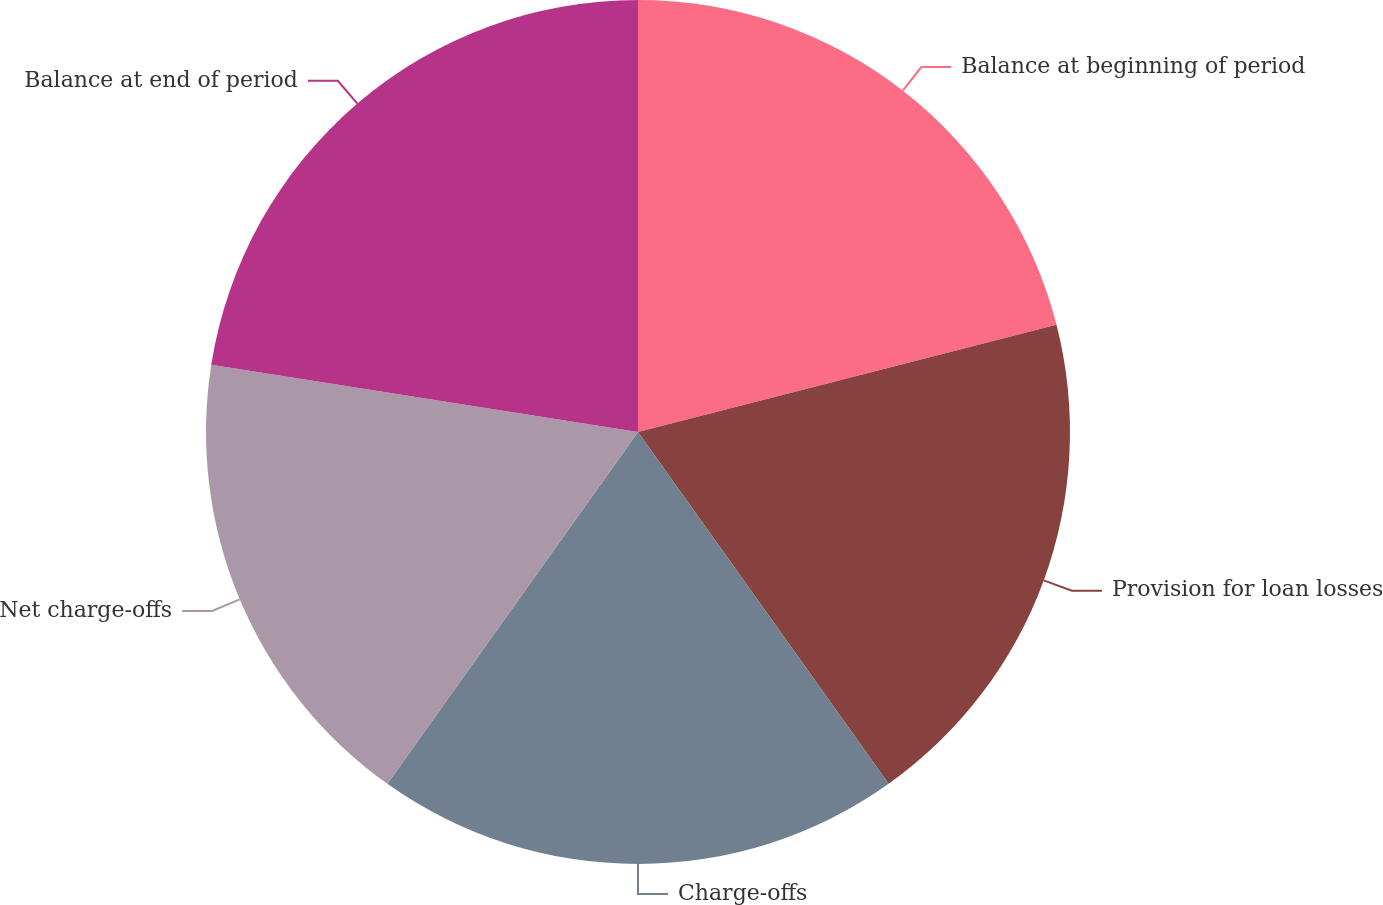Convert chart. <chart><loc_0><loc_0><loc_500><loc_500><pie_chart><fcel>Balance at beginning of period<fcel>Provision for loan losses<fcel>Charge-offs<fcel>Net charge-offs<fcel>Balance at end of period<nl><fcel>21.01%<fcel>19.14%<fcel>19.7%<fcel>17.64%<fcel>22.51%<nl></chart> 